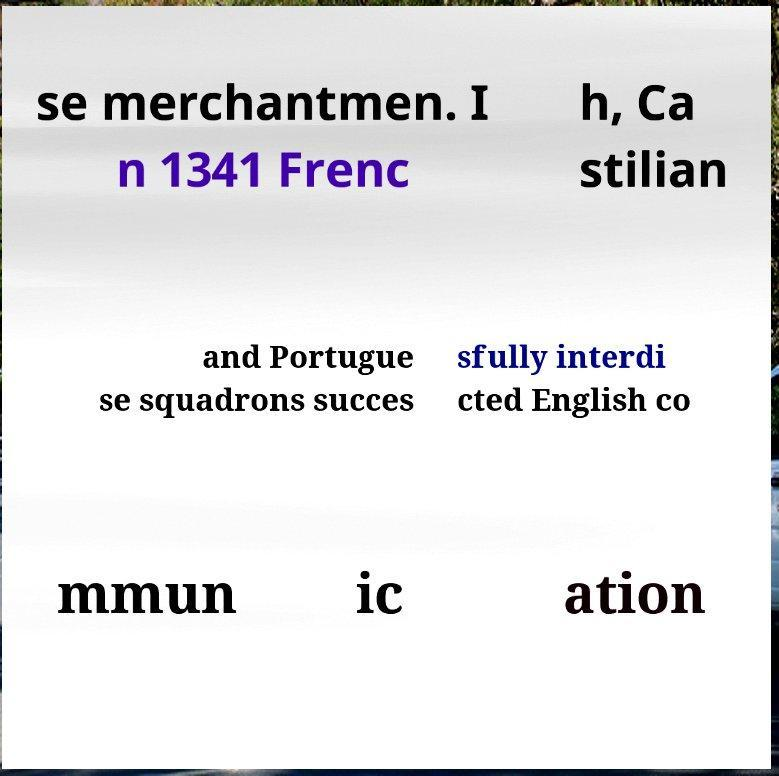I need the written content from this picture converted into text. Can you do that? se merchantmen. I n 1341 Frenc h, Ca stilian and Portugue se squadrons succes sfully interdi cted English co mmun ic ation 